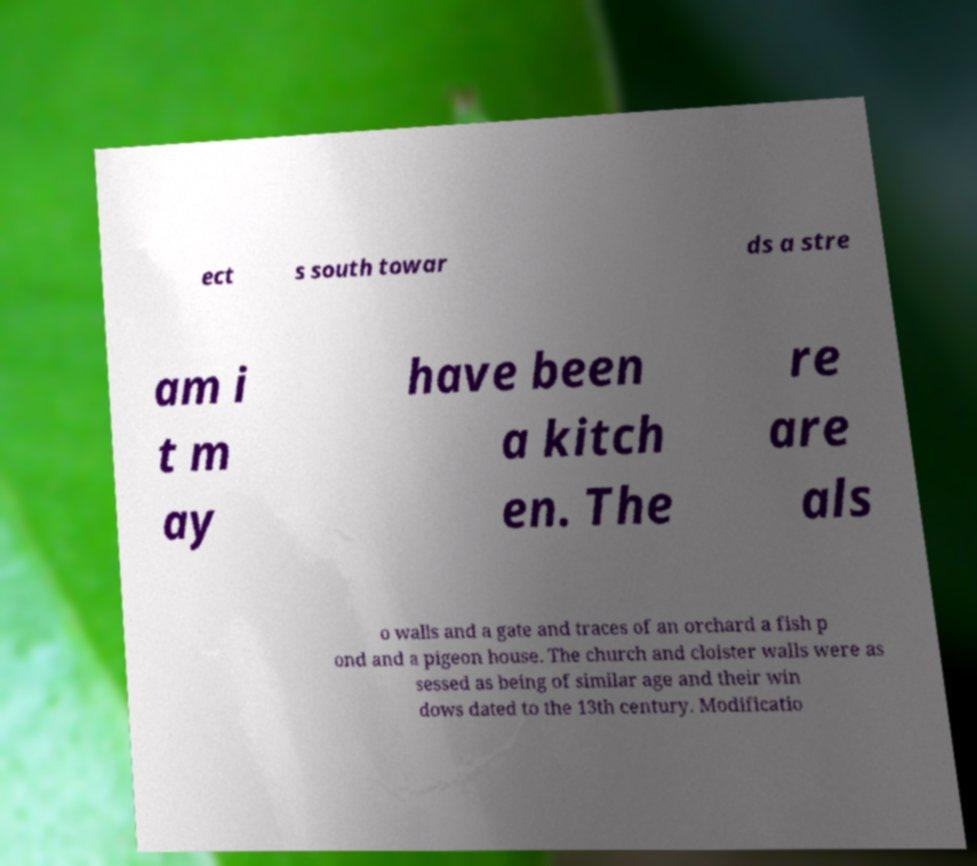Could you assist in decoding the text presented in this image and type it out clearly? ect s south towar ds a stre am i t m ay have been a kitch en. The re are als o walls and a gate and traces of an orchard a fish p ond and a pigeon house. The church and cloister walls were as sessed as being of similar age and their win dows dated to the 13th century. Modificatio 